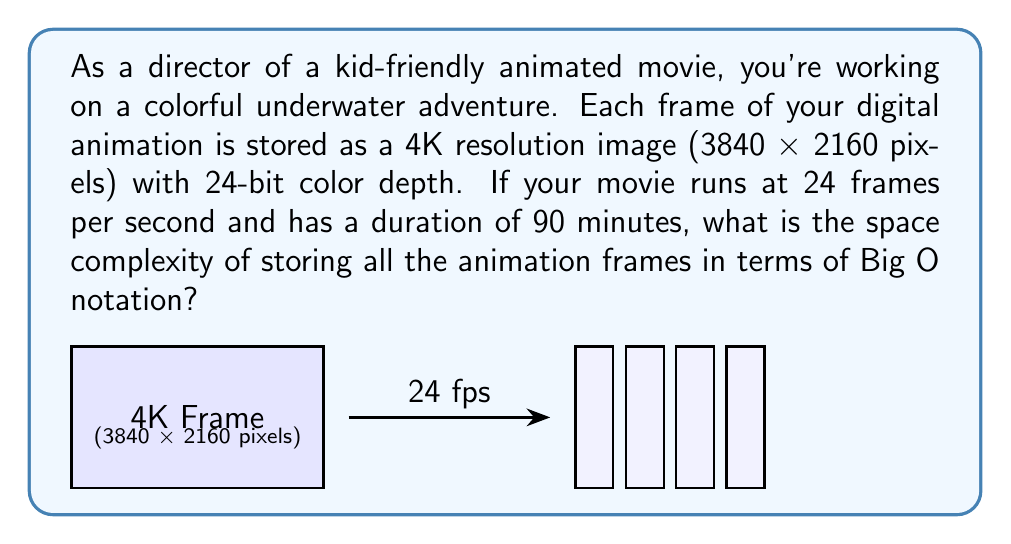Could you help me with this problem? Let's break this down step-by-step:

1) First, calculate the number of pixels in each frame:
   $3840 \times 2160 = 8,294,400$ pixels

2) Each pixel uses 24-bit color depth, which is 3 bytes:
   $8,294,400 \times 3 = 24,883,200$ bytes per frame

3) Calculate the number of frames in the movie:
   90 minutes = 5400 seconds
   At 24 frames per second: $5400 \times 24 = 129,600$ frames

4) Calculate the total storage needed:
   $24,883,200 \times 129,600 = 3,224,862,720,000$ bytes

5) Convert to a more readable format:
   $3,224,862,720,000$ bytes ≈ 3.22 TB

6) For space complexity in Big O notation, we're interested in how the storage requirements grow with respect to the input size. In this case, the input size can be considered as the number of frames (n).

7) The space required is directly proportional to the number of frames. Each frame takes a constant amount of space (24,883,200 bytes), and we're storing n frames.

8) This linear relationship is expressed in Big O notation as O(n).
Answer: O(n) 